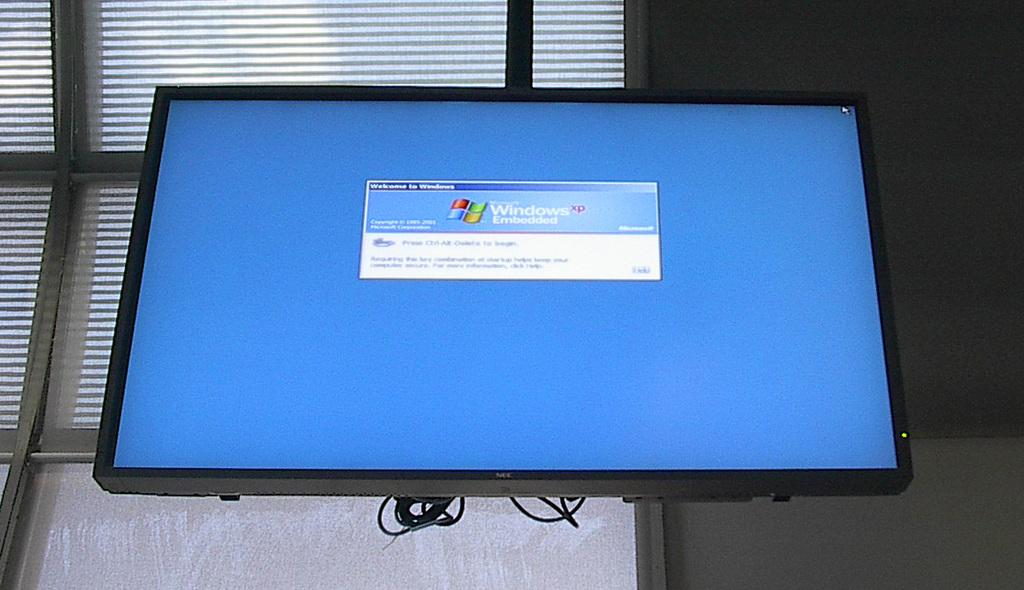<image>
Relay a brief, clear account of the picture shown. A large screen with a sign that says "windows embedded" on it 